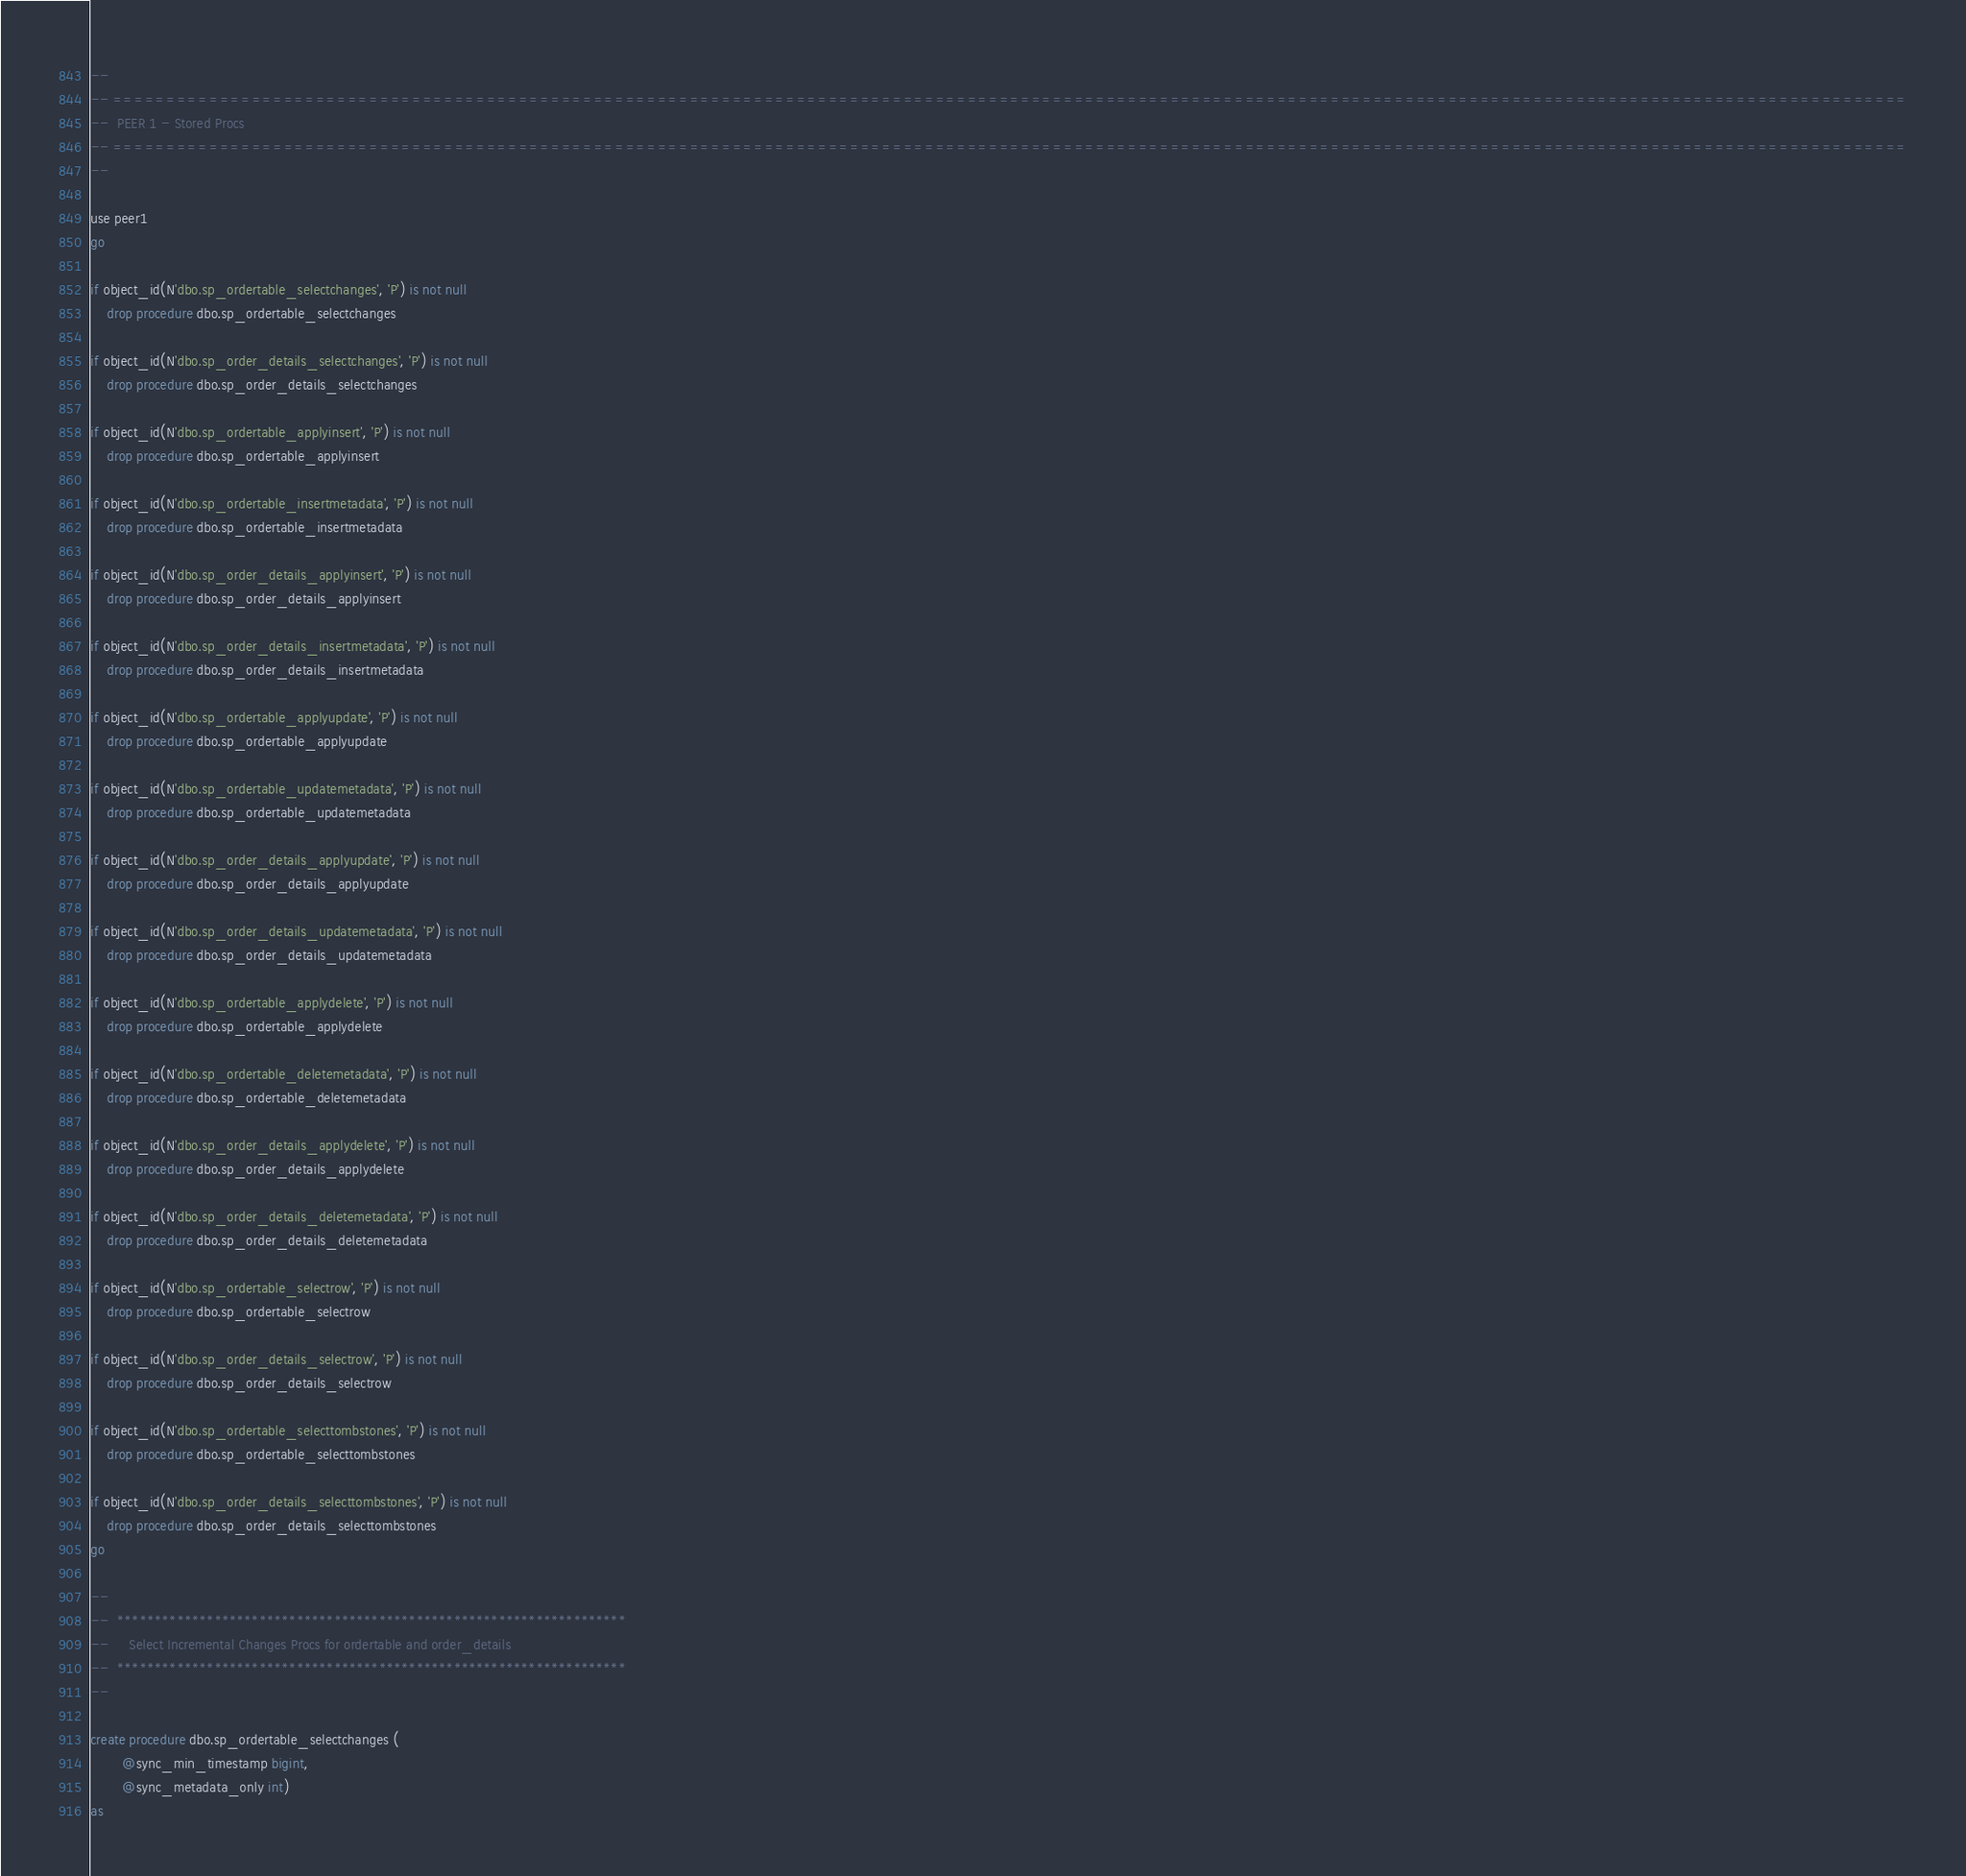<code> <loc_0><loc_0><loc_500><loc_500><_SQL_>--
-- ========================================================================================================================================================================
--  PEER 1 - Stored Procs
-- ========================================================================================================================================================================
--

use peer1
go

if object_id(N'dbo.sp_ordertable_selectchanges', 'P') is not null
	drop procedure dbo.sp_ordertable_selectchanges

if object_id(N'dbo.sp_order_details_selectchanges', 'P') is not null
	drop procedure dbo.sp_order_details_selectchanges

if object_id(N'dbo.sp_ordertable_applyinsert', 'P') is not null
	drop procedure dbo.sp_ordertable_applyinsert

if object_id(N'dbo.sp_ordertable_insertmetadata', 'P') is not null
	drop procedure dbo.sp_ordertable_insertmetadata

if object_id(N'dbo.sp_order_details_applyinsert', 'P') is not null
	drop procedure dbo.sp_order_details_applyinsert

if object_id(N'dbo.sp_order_details_insertmetadata', 'P') is not null
	drop procedure dbo.sp_order_details_insertmetadata

if object_id(N'dbo.sp_ordertable_applyupdate', 'P') is not null
	drop procedure dbo.sp_ordertable_applyupdate

if object_id(N'dbo.sp_ordertable_updatemetadata', 'P') is not null
	drop procedure dbo.sp_ordertable_updatemetadata

if object_id(N'dbo.sp_order_details_applyupdate', 'P') is not null
	drop procedure dbo.sp_order_details_applyupdate

if object_id(N'dbo.sp_order_details_updatemetadata', 'P') is not null
	drop procedure dbo.sp_order_details_updatemetadata

if object_id(N'dbo.sp_ordertable_applydelete', 'P') is not null
	drop procedure dbo.sp_ordertable_applydelete

if object_id(N'dbo.sp_ordertable_deletemetadata', 'P') is not null
	drop procedure dbo.sp_ordertable_deletemetadata

if object_id(N'dbo.sp_order_details_applydelete', 'P') is not null
	drop procedure dbo.sp_order_details_applydelete

if object_id(N'dbo.sp_order_details_deletemetadata', 'P') is not null
	drop procedure dbo.sp_order_details_deletemetadata

if object_id(N'dbo.sp_ordertable_selectrow', 'P') is not null
	drop procedure dbo.sp_ordertable_selectrow

if object_id(N'dbo.sp_order_details_selectrow', 'P') is not null
	drop procedure dbo.sp_order_details_selectrow

if object_id(N'dbo.sp_ordertable_selecttombstones', 'P') is not null
	drop procedure dbo.sp_ordertable_selecttombstones

if object_id(N'dbo.sp_order_details_selecttombstones', 'P') is not null
	drop procedure dbo.sp_order_details_selecttombstones
go

--
--  ********************************************************************
--     Select Incremental Changes Procs for ordertable and order_details
--  ********************************************************************
--

create procedure dbo.sp_ordertable_selectchanges (				
		@sync_min_timestamp bigint,		
		@sync_metadata_only int)
as    </code> 